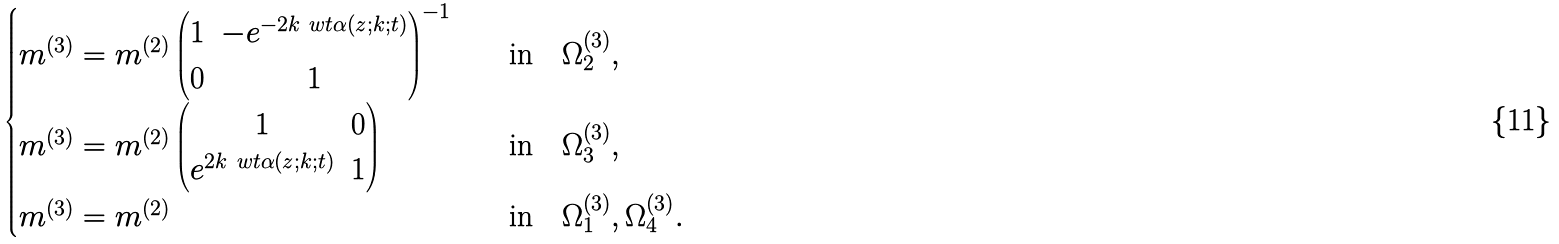Convert formula to latex. <formula><loc_0><loc_0><loc_500><loc_500>\begin{cases} m ^ { ( 3 ) } = m ^ { ( 2 ) } \begin{pmatrix} 1 & - e ^ { - 2 k \ w t { \alpha } ( z ; k ; t ) } \\ 0 & 1 \end{pmatrix} ^ { - 1 } \quad & \text {in} \quad \Omega ^ { ( 3 ) } _ { 2 } , \\ m ^ { ( 3 ) } = m ^ { ( 2 ) } \begin{pmatrix} 1 & 0 \\ e ^ { 2 k \ w t { \alpha } ( z ; k ; t ) } & 1 \end{pmatrix} \quad & \text {in} \quad \Omega ^ { ( 3 ) } _ { 3 } , \\ m ^ { ( 3 ) } = m ^ { ( 2 ) } \quad & \text {in} \quad \Omega ^ { ( 3 ) } _ { 1 } , \Omega ^ { ( 3 ) } _ { 4 } . \end{cases}</formula> 